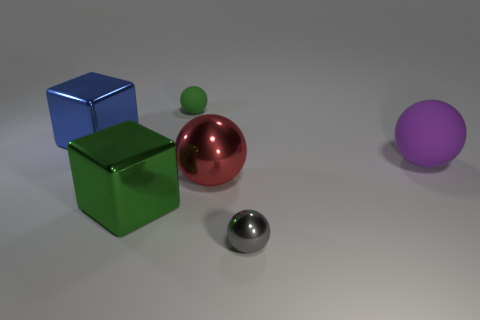What number of other large balls have the same color as the large matte ball?
Keep it short and to the point. 0. The object that is the same size as the green matte ball is what shape?
Provide a succinct answer. Sphere. Are there any green metal objects of the same size as the gray object?
Your answer should be compact. No. What material is the green sphere that is the same size as the gray object?
Offer a very short reply. Rubber. There is a rubber sphere that is right of the sphere on the left side of the red ball; what is its size?
Provide a succinct answer. Large. Do the green thing that is behind the purple sphere and the small shiny object have the same size?
Ensure brevity in your answer.  Yes. Is the number of tiny green matte spheres to the right of the big purple object greater than the number of shiny cubes that are in front of the tiny green thing?
Ensure brevity in your answer.  No. What is the shape of the shiny thing that is both in front of the blue object and on the left side of the green sphere?
Make the answer very short. Cube. There is a matte thing right of the large shiny ball; what is its shape?
Give a very brief answer. Sphere. What is the size of the metal object to the left of the metallic cube that is on the right side of the large shiny object that is behind the big purple thing?
Give a very brief answer. Large. 